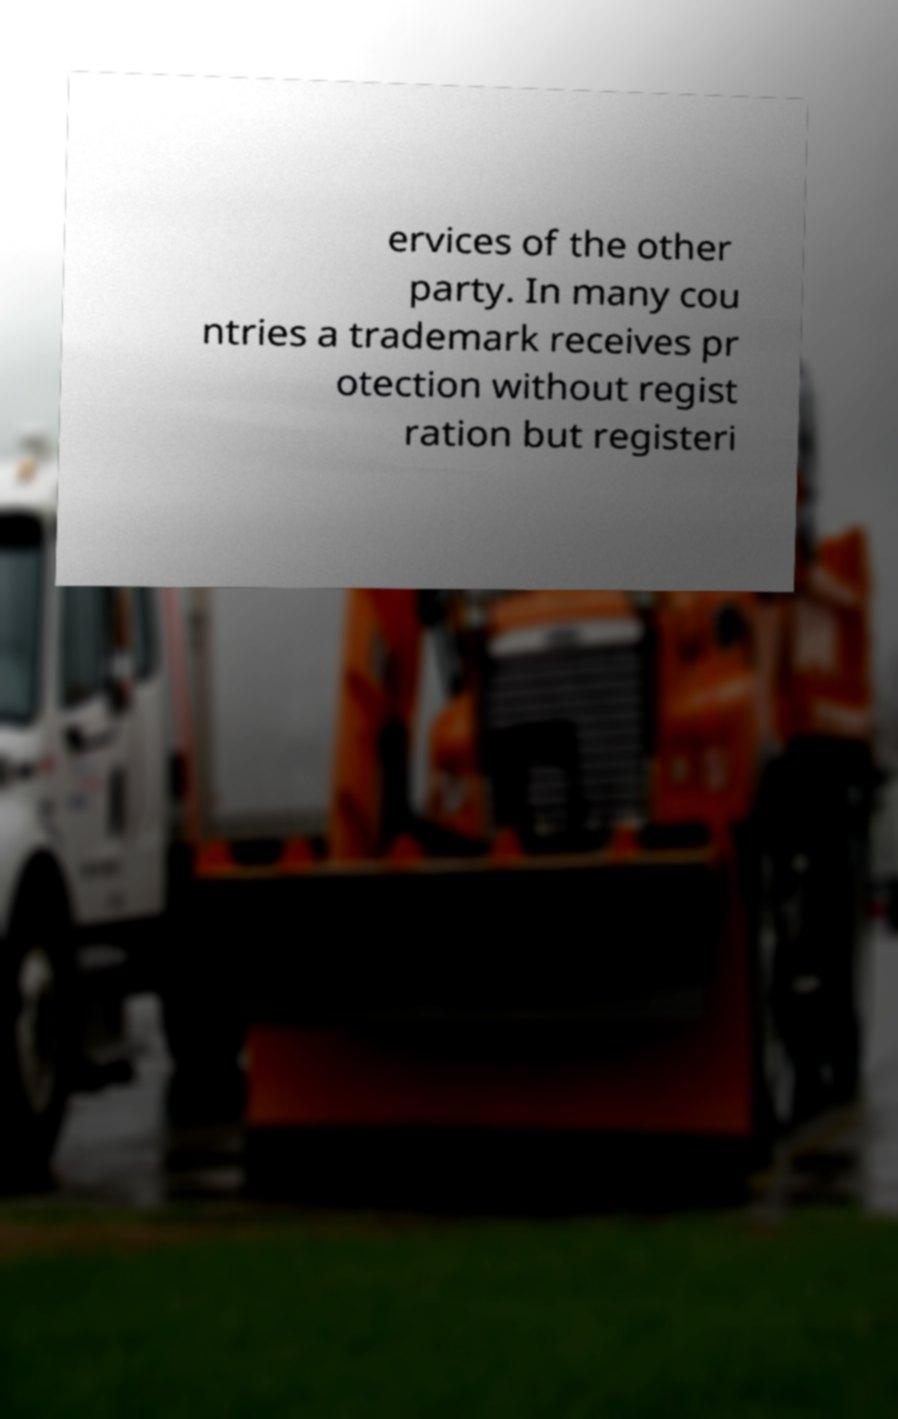Could you assist in decoding the text presented in this image and type it out clearly? ervices of the other party. In many cou ntries a trademark receives pr otection without regist ration but registeri 